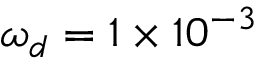<formula> <loc_0><loc_0><loc_500><loc_500>\omega _ { d } = 1 \times 1 0 ^ { - 3 }</formula> 